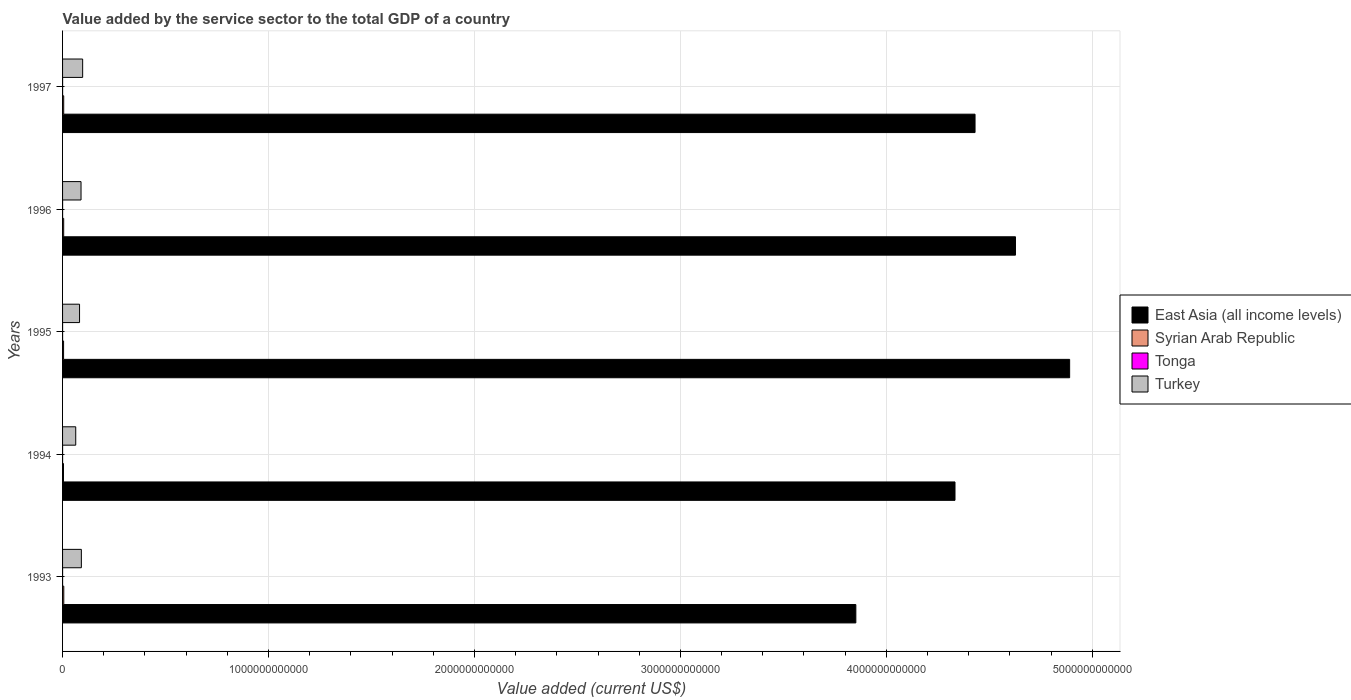Are the number of bars per tick equal to the number of legend labels?
Provide a short and direct response. Yes. Are the number of bars on each tick of the Y-axis equal?
Your answer should be very brief. Yes. In how many cases, is the number of bars for a given year not equal to the number of legend labels?
Offer a very short reply. 0. What is the value added by the service sector to the total GDP in Syrian Arab Republic in 1994?
Your response must be concise. 4.43e+09. Across all years, what is the maximum value added by the service sector to the total GDP in Tonga?
Give a very brief answer. 1.03e+08. Across all years, what is the minimum value added by the service sector to the total GDP in Syrian Arab Republic?
Provide a short and direct response. 4.43e+09. In which year was the value added by the service sector to the total GDP in East Asia (all income levels) maximum?
Offer a terse response. 1995. In which year was the value added by the service sector to the total GDP in Turkey minimum?
Keep it short and to the point. 1994. What is the total value added by the service sector to the total GDP in Turkey in the graph?
Your response must be concise. 4.25e+11. What is the difference between the value added by the service sector to the total GDP in Turkey in 1994 and that in 1995?
Your response must be concise. -1.85e+1. What is the difference between the value added by the service sector to the total GDP in Tonga in 1995 and the value added by the service sector to the total GDP in Turkey in 1997?
Your response must be concise. -9.75e+1. What is the average value added by the service sector to the total GDP in Syrian Arab Republic per year?
Your response must be concise. 5.23e+09. In the year 1995, what is the difference between the value added by the service sector to the total GDP in Syrian Arab Republic and value added by the service sector to the total GDP in East Asia (all income levels)?
Your answer should be compact. -4.88e+12. What is the ratio of the value added by the service sector to the total GDP in Turkey in 1994 to that in 1996?
Offer a very short reply. 0.71. Is the value added by the service sector to the total GDP in Turkey in 1996 less than that in 1997?
Your answer should be very brief. Yes. Is the difference between the value added by the service sector to the total GDP in Syrian Arab Republic in 1995 and 1997 greater than the difference between the value added by the service sector to the total GDP in East Asia (all income levels) in 1995 and 1997?
Offer a terse response. No. What is the difference between the highest and the second highest value added by the service sector to the total GDP in East Asia (all income levels)?
Your response must be concise. 2.63e+11. What is the difference between the highest and the lowest value added by the service sector to the total GDP in Tonga?
Your answer should be compact. 4.81e+07. In how many years, is the value added by the service sector to the total GDP in East Asia (all income levels) greater than the average value added by the service sector to the total GDP in East Asia (all income levels) taken over all years?
Ensure brevity in your answer.  3. Is the sum of the value added by the service sector to the total GDP in Tonga in 1993 and 1997 greater than the maximum value added by the service sector to the total GDP in East Asia (all income levels) across all years?
Ensure brevity in your answer.  No. What does the 2nd bar from the top in 1993 represents?
Give a very brief answer. Tonga. What does the 1st bar from the bottom in 1995 represents?
Make the answer very short. East Asia (all income levels). How many years are there in the graph?
Your answer should be compact. 5. What is the difference between two consecutive major ticks on the X-axis?
Your answer should be compact. 1.00e+12. Are the values on the major ticks of X-axis written in scientific E-notation?
Your answer should be compact. No. Does the graph contain any zero values?
Give a very brief answer. No. Where does the legend appear in the graph?
Keep it short and to the point. Center right. What is the title of the graph?
Provide a succinct answer. Value added by the service sector to the total GDP of a country. Does "Liberia" appear as one of the legend labels in the graph?
Your response must be concise. No. What is the label or title of the X-axis?
Offer a very short reply. Value added (current US$). What is the Value added (current US$) of East Asia (all income levels) in 1993?
Your response must be concise. 3.85e+12. What is the Value added (current US$) of Syrian Arab Republic in 1993?
Ensure brevity in your answer.  5.89e+09. What is the Value added (current US$) of Tonga in 1993?
Your response must be concise. 5.46e+07. What is the Value added (current US$) in Turkey in 1993?
Ensure brevity in your answer.  9.13e+1. What is the Value added (current US$) in East Asia (all income levels) in 1994?
Your response must be concise. 4.33e+12. What is the Value added (current US$) in Syrian Arab Republic in 1994?
Give a very brief answer. 4.43e+09. What is the Value added (current US$) of Tonga in 1994?
Ensure brevity in your answer.  9.02e+07. What is the Value added (current US$) in Turkey in 1994?
Offer a very short reply. 6.40e+1. What is the Value added (current US$) in East Asia (all income levels) in 1995?
Provide a short and direct response. 4.89e+12. What is the Value added (current US$) of Syrian Arab Republic in 1995?
Your answer should be compact. 4.90e+09. What is the Value added (current US$) in Tonga in 1995?
Your answer should be compact. 9.17e+07. What is the Value added (current US$) in Turkey in 1995?
Your answer should be compact. 8.24e+1. What is the Value added (current US$) in East Asia (all income levels) in 1996?
Give a very brief answer. 4.63e+12. What is the Value added (current US$) in Syrian Arab Republic in 1996?
Ensure brevity in your answer.  5.42e+09. What is the Value added (current US$) in Tonga in 1996?
Give a very brief answer. 1.03e+08. What is the Value added (current US$) of Turkey in 1996?
Ensure brevity in your answer.  8.97e+1. What is the Value added (current US$) of East Asia (all income levels) in 1997?
Offer a very short reply. 4.43e+12. What is the Value added (current US$) in Syrian Arab Republic in 1997?
Ensure brevity in your answer.  5.53e+09. What is the Value added (current US$) of Tonga in 1997?
Offer a very short reply. 1.03e+08. What is the Value added (current US$) in Turkey in 1997?
Offer a very short reply. 9.76e+1. Across all years, what is the maximum Value added (current US$) of East Asia (all income levels)?
Ensure brevity in your answer.  4.89e+12. Across all years, what is the maximum Value added (current US$) of Syrian Arab Republic?
Offer a very short reply. 5.89e+09. Across all years, what is the maximum Value added (current US$) of Tonga?
Provide a short and direct response. 1.03e+08. Across all years, what is the maximum Value added (current US$) in Turkey?
Your answer should be compact. 9.76e+1. Across all years, what is the minimum Value added (current US$) in East Asia (all income levels)?
Keep it short and to the point. 3.85e+12. Across all years, what is the minimum Value added (current US$) of Syrian Arab Republic?
Give a very brief answer. 4.43e+09. Across all years, what is the minimum Value added (current US$) in Tonga?
Make the answer very short. 5.46e+07. Across all years, what is the minimum Value added (current US$) of Turkey?
Offer a terse response. 6.40e+1. What is the total Value added (current US$) of East Asia (all income levels) in the graph?
Make the answer very short. 2.21e+13. What is the total Value added (current US$) of Syrian Arab Republic in the graph?
Your response must be concise. 2.62e+1. What is the total Value added (current US$) in Tonga in the graph?
Provide a short and direct response. 4.42e+08. What is the total Value added (current US$) of Turkey in the graph?
Your response must be concise. 4.25e+11. What is the difference between the Value added (current US$) in East Asia (all income levels) in 1993 and that in 1994?
Provide a short and direct response. -4.81e+11. What is the difference between the Value added (current US$) of Syrian Arab Republic in 1993 and that in 1994?
Provide a succinct answer. 1.47e+09. What is the difference between the Value added (current US$) in Tonga in 1993 and that in 1994?
Make the answer very short. -3.56e+07. What is the difference between the Value added (current US$) in Turkey in 1993 and that in 1994?
Give a very brief answer. 2.73e+1. What is the difference between the Value added (current US$) in East Asia (all income levels) in 1993 and that in 1995?
Provide a short and direct response. -1.04e+12. What is the difference between the Value added (current US$) of Syrian Arab Republic in 1993 and that in 1995?
Ensure brevity in your answer.  9.92e+08. What is the difference between the Value added (current US$) of Tonga in 1993 and that in 1995?
Your answer should be very brief. -3.71e+07. What is the difference between the Value added (current US$) in Turkey in 1993 and that in 1995?
Offer a very short reply. 8.86e+09. What is the difference between the Value added (current US$) in East Asia (all income levels) in 1993 and that in 1996?
Your answer should be compact. -7.75e+11. What is the difference between the Value added (current US$) of Syrian Arab Republic in 1993 and that in 1996?
Provide a short and direct response. 4.74e+08. What is the difference between the Value added (current US$) of Tonga in 1993 and that in 1996?
Provide a succinct answer. -4.80e+07. What is the difference between the Value added (current US$) of Turkey in 1993 and that in 1996?
Your answer should be compact. 1.59e+09. What is the difference between the Value added (current US$) in East Asia (all income levels) in 1993 and that in 1997?
Keep it short and to the point. -5.79e+11. What is the difference between the Value added (current US$) in Syrian Arab Republic in 1993 and that in 1997?
Offer a very short reply. 3.67e+08. What is the difference between the Value added (current US$) of Tonga in 1993 and that in 1997?
Your answer should be very brief. -4.81e+07. What is the difference between the Value added (current US$) in Turkey in 1993 and that in 1997?
Keep it short and to the point. -6.27e+09. What is the difference between the Value added (current US$) in East Asia (all income levels) in 1994 and that in 1995?
Make the answer very short. -5.57e+11. What is the difference between the Value added (current US$) in Syrian Arab Republic in 1994 and that in 1995?
Provide a short and direct response. -4.74e+08. What is the difference between the Value added (current US$) of Tonga in 1994 and that in 1995?
Keep it short and to the point. -1.53e+06. What is the difference between the Value added (current US$) in Turkey in 1994 and that in 1995?
Keep it short and to the point. -1.85e+1. What is the difference between the Value added (current US$) in East Asia (all income levels) in 1994 and that in 1996?
Provide a succinct answer. -2.94e+11. What is the difference between the Value added (current US$) in Syrian Arab Republic in 1994 and that in 1996?
Make the answer very short. -9.91e+08. What is the difference between the Value added (current US$) in Tonga in 1994 and that in 1996?
Provide a succinct answer. -1.24e+07. What is the difference between the Value added (current US$) of Turkey in 1994 and that in 1996?
Offer a terse response. -2.57e+1. What is the difference between the Value added (current US$) of East Asia (all income levels) in 1994 and that in 1997?
Give a very brief answer. -9.73e+1. What is the difference between the Value added (current US$) of Syrian Arab Republic in 1994 and that in 1997?
Provide a succinct answer. -1.10e+09. What is the difference between the Value added (current US$) in Tonga in 1994 and that in 1997?
Provide a succinct answer. -1.25e+07. What is the difference between the Value added (current US$) of Turkey in 1994 and that in 1997?
Ensure brevity in your answer.  -3.36e+1. What is the difference between the Value added (current US$) in East Asia (all income levels) in 1995 and that in 1996?
Offer a very short reply. 2.63e+11. What is the difference between the Value added (current US$) of Syrian Arab Republic in 1995 and that in 1996?
Keep it short and to the point. -5.17e+08. What is the difference between the Value added (current US$) in Tonga in 1995 and that in 1996?
Provide a short and direct response. -1.09e+07. What is the difference between the Value added (current US$) of Turkey in 1995 and that in 1996?
Offer a very short reply. -7.28e+09. What is the difference between the Value added (current US$) of East Asia (all income levels) in 1995 and that in 1997?
Offer a terse response. 4.59e+11. What is the difference between the Value added (current US$) of Syrian Arab Republic in 1995 and that in 1997?
Keep it short and to the point. -6.25e+08. What is the difference between the Value added (current US$) of Tonga in 1995 and that in 1997?
Your answer should be very brief. -1.10e+07. What is the difference between the Value added (current US$) in Turkey in 1995 and that in 1997?
Ensure brevity in your answer.  -1.51e+1. What is the difference between the Value added (current US$) in East Asia (all income levels) in 1996 and that in 1997?
Your answer should be very brief. 1.96e+11. What is the difference between the Value added (current US$) of Syrian Arab Republic in 1996 and that in 1997?
Make the answer very short. -1.07e+08. What is the difference between the Value added (current US$) in Tonga in 1996 and that in 1997?
Offer a terse response. -1.17e+05. What is the difference between the Value added (current US$) of Turkey in 1996 and that in 1997?
Your response must be concise. -7.86e+09. What is the difference between the Value added (current US$) in East Asia (all income levels) in 1993 and the Value added (current US$) in Syrian Arab Republic in 1994?
Offer a terse response. 3.85e+12. What is the difference between the Value added (current US$) in East Asia (all income levels) in 1993 and the Value added (current US$) in Tonga in 1994?
Offer a terse response. 3.85e+12. What is the difference between the Value added (current US$) in East Asia (all income levels) in 1993 and the Value added (current US$) in Turkey in 1994?
Offer a terse response. 3.79e+12. What is the difference between the Value added (current US$) of Syrian Arab Republic in 1993 and the Value added (current US$) of Tonga in 1994?
Your answer should be very brief. 5.80e+09. What is the difference between the Value added (current US$) of Syrian Arab Republic in 1993 and the Value added (current US$) of Turkey in 1994?
Make the answer very short. -5.81e+1. What is the difference between the Value added (current US$) in Tonga in 1993 and the Value added (current US$) in Turkey in 1994?
Make the answer very short. -6.39e+1. What is the difference between the Value added (current US$) of East Asia (all income levels) in 1993 and the Value added (current US$) of Syrian Arab Republic in 1995?
Your response must be concise. 3.85e+12. What is the difference between the Value added (current US$) in East Asia (all income levels) in 1993 and the Value added (current US$) in Tonga in 1995?
Give a very brief answer. 3.85e+12. What is the difference between the Value added (current US$) of East Asia (all income levels) in 1993 and the Value added (current US$) of Turkey in 1995?
Your answer should be compact. 3.77e+12. What is the difference between the Value added (current US$) of Syrian Arab Republic in 1993 and the Value added (current US$) of Tonga in 1995?
Offer a very short reply. 5.80e+09. What is the difference between the Value added (current US$) of Syrian Arab Republic in 1993 and the Value added (current US$) of Turkey in 1995?
Make the answer very short. -7.65e+1. What is the difference between the Value added (current US$) of Tonga in 1993 and the Value added (current US$) of Turkey in 1995?
Provide a succinct answer. -8.24e+1. What is the difference between the Value added (current US$) of East Asia (all income levels) in 1993 and the Value added (current US$) of Syrian Arab Republic in 1996?
Keep it short and to the point. 3.85e+12. What is the difference between the Value added (current US$) in East Asia (all income levels) in 1993 and the Value added (current US$) in Tonga in 1996?
Offer a very short reply. 3.85e+12. What is the difference between the Value added (current US$) of East Asia (all income levels) in 1993 and the Value added (current US$) of Turkey in 1996?
Offer a terse response. 3.76e+12. What is the difference between the Value added (current US$) in Syrian Arab Republic in 1993 and the Value added (current US$) in Tonga in 1996?
Provide a short and direct response. 5.79e+09. What is the difference between the Value added (current US$) in Syrian Arab Republic in 1993 and the Value added (current US$) in Turkey in 1996?
Ensure brevity in your answer.  -8.38e+1. What is the difference between the Value added (current US$) in Tonga in 1993 and the Value added (current US$) in Turkey in 1996?
Provide a short and direct response. -8.96e+1. What is the difference between the Value added (current US$) of East Asia (all income levels) in 1993 and the Value added (current US$) of Syrian Arab Republic in 1997?
Your answer should be very brief. 3.85e+12. What is the difference between the Value added (current US$) of East Asia (all income levels) in 1993 and the Value added (current US$) of Tonga in 1997?
Provide a short and direct response. 3.85e+12. What is the difference between the Value added (current US$) in East Asia (all income levels) in 1993 and the Value added (current US$) in Turkey in 1997?
Make the answer very short. 3.75e+12. What is the difference between the Value added (current US$) of Syrian Arab Republic in 1993 and the Value added (current US$) of Tonga in 1997?
Your answer should be very brief. 5.79e+09. What is the difference between the Value added (current US$) in Syrian Arab Republic in 1993 and the Value added (current US$) in Turkey in 1997?
Provide a short and direct response. -9.17e+1. What is the difference between the Value added (current US$) of Tonga in 1993 and the Value added (current US$) of Turkey in 1997?
Make the answer very short. -9.75e+1. What is the difference between the Value added (current US$) of East Asia (all income levels) in 1994 and the Value added (current US$) of Syrian Arab Republic in 1995?
Keep it short and to the point. 4.33e+12. What is the difference between the Value added (current US$) of East Asia (all income levels) in 1994 and the Value added (current US$) of Tonga in 1995?
Give a very brief answer. 4.33e+12. What is the difference between the Value added (current US$) of East Asia (all income levels) in 1994 and the Value added (current US$) of Turkey in 1995?
Your answer should be compact. 4.25e+12. What is the difference between the Value added (current US$) in Syrian Arab Republic in 1994 and the Value added (current US$) in Tonga in 1995?
Give a very brief answer. 4.34e+09. What is the difference between the Value added (current US$) of Syrian Arab Republic in 1994 and the Value added (current US$) of Turkey in 1995?
Provide a succinct answer. -7.80e+1. What is the difference between the Value added (current US$) of Tonga in 1994 and the Value added (current US$) of Turkey in 1995?
Offer a terse response. -8.23e+1. What is the difference between the Value added (current US$) in East Asia (all income levels) in 1994 and the Value added (current US$) in Syrian Arab Republic in 1996?
Your response must be concise. 4.33e+12. What is the difference between the Value added (current US$) of East Asia (all income levels) in 1994 and the Value added (current US$) of Tonga in 1996?
Provide a short and direct response. 4.33e+12. What is the difference between the Value added (current US$) of East Asia (all income levels) in 1994 and the Value added (current US$) of Turkey in 1996?
Your answer should be compact. 4.24e+12. What is the difference between the Value added (current US$) of Syrian Arab Republic in 1994 and the Value added (current US$) of Tonga in 1996?
Your response must be concise. 4.32e+09. What is the difference between the Value added (current US$) in Syrian Arab Republic in 1994 and the Value added (current US$) in Turkey in 1996?
Offer a terse response. -8.53e+1. What is the difference between the Value added (current US$) in Tonga in 1994 and the Value added (current US$) in Turkey in 1996?
Make the answer very short. -8.96e+1. What is the difference between the Value added (current US$) in East Asia (all income levels) in 1994 and the Value added (current US$) in Syrian Arab Republic in 1997?
Ensure brevity in your answer.  4.33e+12. What is the difference between the Value added (current US$) in East Asia (all income levels) in 1994 and the Value added (current US$) in Tonga in 1997?
Your response must be concise. 4.33e+12. What is the difference between the Value added (current US$) in East Asia (all income levels) in 1994 and the Value added (current US$) in Turkey in 1997?
Provide a short and direct response. 4.24e+12. What is the difference between the Value added (current US$) in Syrian Arab Republic in 1994 and the Value added (current US$) in Tonga in 1997?
Keep it short and to the point. 4.32e+09. What is the difference between the Value added (current US$) in Syrian Arab Republic in 1994 and the Value added (current US$) in Turkey in 1997?
Give a very brief answer. -9.31e+1. What is the difference between the Value added (current US$) of Tonga in 1994 and the Value added (current US$) of Turkey in 1997?
Offer a very short reply. -9.75e+1. What is the difference between the Value added (current US$) of East Asia (all income levels) in 1995 and the Value added (current US$) of Syrian Arab Republic in 1996?
Provide a short and direct response. 4.88e+12. What is the difference between the Value added (current US$) in East Asia (all income levels) in 1995 and the Value added (current US$) in Tonga in 1996?
Make the answer very short. 4.89e+12. What is the difference between the Value added (current US$) of East Asia (all income levels) in 1995 and the Value added (current US$) of Turkey in 1996?
Ensure brevity in your answer.  4.80e+12. What is the difference between the Value added (current US$) of Syrian Arab Republic in 1995 and the Value added (current US$) of Tonga in 1996?
Make the answer very short. 4.80e+09. What is the difference between the Value added (current US$) in Syrian Arab Republic in 1995 and the Value added (current US$) in Turkey in 1996?
Your answer should be compact. -8.48e+1. What is the difference between the Value added (current US$) in Tonga in 1995 and the Value added (current US$) in Turkey in 1996?
Ensure brevity in your answer.  -8.96e+1. What is the difference between the Value added (current US$) of East Asia (all income levels) in 1995 and the Value added (current US$) of Syrian Arab Republic in 1997?
Provide a succinct answer. 4.88e+12. What is the difference between the Value added (current US$) in East Asia (all income levels) in 1995 and the Value added (current US$) in Tonga in 1997?
Make the answer very short. 4.89e+12. What is the difference between the Value added (current US$) of East Asia (all income levels) in 1995 and the Value added (current US$) of Turkey in 1997?
Give a very brief answer. 4.79e+12. What is the difference between the Value added (current US$) in Syrian Arab Republic in 1995 and the Value added (current US$) in Tonga in 1997?
Offer a very short reply. 4.80e+09. What is the difference between the Value added (current US$) in Syrian Arab Republic in 1995 and the Value added (current US$) in Turkey in 1997?
Your answer should be compact. -9.27e+1. What is the difference between the Value added (current US$) of Tonga in 1995 and the Value added (current US$) of Turkey in 1997?
Provide a succinct answer. -9.75e+1. What is the difference between the Value added (current US$) in East Asia (all income levels) in 1996 and the Value added (current US$) in Syrian Arab Republic in 1997?
Ensure brevity in your answer.  4.62e+12. What is the difference between the Value added (current US$) in East Asia (all income levels) in 1996 and the Value added (current US$) in Tonga in 1997?
Keep it short and to the point. 4.63e+12. What is the difference between the Value added (current US$) in East Asia (all income levels) in 1996 and the Value added (current US$) in Turkey in 1997?
Ensure brevity in your answer.  4.53e+12. What is the difference between the Value added (current US$) of Syrian Arab Republic in 1996 and the Value added (current US$) of Tonga in 1997?
Provide a short and direct response. 5.32e+09. What is the difference between the Value added (current US$) in Syrian Arab Republic in 1996 and the Value added (current US$) in Turkey in 1997?
Provide a short and direct response. -9.21e+1. What is the difference between the Value added (current US$) of Tonga in 1996 and the Value added (current US$) of Turkey in 1997?
Offer a very short reply. -9.74e+1. What is the average Value added (current US$) of East Asia (all income levels) per year?
Your answer should be compact. 4.43e+12. What is the average Value added (current US$) of Syrian Arab Republic per year?
Ensure brevity in your answer.  5.23e+09. What is the average Value added (current US$) in Tonga per year?
Your answer should be very brief. 8.84e+07. What is the average Value added (current US$) of Turkey per year?
Offer a very short reply. 8.50e+1. In the year 1993, what is the difference between the Value added (current US$) in East Asia (all income levels) and Value added (current US$) in Syrian Arab Republic?
Offer a very short reply. 3.85e+12. In the year 1993, what is the difference between the Value added (current US$) in East Asia (all income levels) and Value added (current US$) in Tonga?
Provide a succinct answer. 3.85e+12. In the year 1993, what is the difference between the Value added (current US$) in East Asia (all income levels) and Value added (current US$) in Turkey?
Ensure brevity in your answer.  3.76e+12. In the year 1993, what is the difference between the Value added (current US$) in Syrian Arab Republic and Value added (current US$) in Tonga?
Your answer should be very brief. 5.84e+09. In the year 1993, what is the difference between the Value added (current US$) in Syrian Arab Republic and Value added (current US$) in Turkey?
Provide a short and direct response. -8.54e+1. In the year 1993, what is the difference between the Value added (current US$) of Tonga and Value added (current US$) of Turkey?
Keep it short and to the point. -9.12e+1. In the year 1994, what is the difference between the Value added (current US$) in East Asia (all income levels) and Value added (current US$) in Syrian Arab Republic?
Give a very brief answer. 4.33e+12. In the year 1994, what is the difference between the Value added (current US$) in East Asia (all income levels) and Value added (current US$) in Tonga?
Give a very brief answer. 4.33e+12. In the year 1994, what is the difference between the Value added (current US$) in East Asia (all income levels) and Value added (current US$) in Turkey?
Your response must be concise. 4.27e+12. In the year 1994, what is the difference between the Value added (current US$) in Syrian Arab Republic and Value added (current US$) in Tonga?
Provide a succinct answer. 4.34e+09. In the year 1994, what is the difference between the Value added (current US$) in Syrian Arab Republic and Value added (current US$) in Turkey?
Ensure brevity in your answer.  -5.95e+1. In the year 1994, what is the difference between the Value added (current US$) of Tonga and Value added (current US$) of Turkey?
Provide a succinct answer. -6.39e+1. In the year 1995, what is the difference between the Value added (current US$) in East Asia (all income levels) and Value added (current US$) in Syrian Arab Republic?
Make the answer very short. 4.88e+12. In the year 1995, what is the difference between the Value added (current US$) in East Asia (all income levels) and Value added (current US$) in Tonga?
Your response must be concise. 4.89e+12. In the year 1995, what is the difference between the Value added (current US$) in East Asia (all income levels) and Value added (current US$) in Turkey?
Offer a terse response. 4.81e+12. In the year 1995, what is the difference between the Value added (current US$) of Syrian Arab Republic and Value added (current US$) of Tonga?
Make the answer very short. 4.81e+09. In the year 1995, what is the difference between the Value added (current US$) of Syrian Arab Republic and Value added (current US$) of Turkey?
Your answer should be compact. -7.75e+1. In the year 1995, what is the difference between the Value added (current US$) in Tonga and Value added (current US$) in Turkey?
Give a very brief answer. -8.23e+1. In the year 1996, what is the difference between the Value added (current US$) of East Asia (all income levels) and Value added (current US$) of Syrian Arab Republic?
Your response must be concise. 4.62e+12. In the year 1996, what is the difference between the Value added (current US$) in East Asia (all income levels) and Value added (current US$) in Tonga?
Provide a succinct answer. 4.63e+12. In the year 1996, what is the difference between the Value added (current US$) in East Asia (all income levels) and Value added (current US$) in Turkey?
Provide a succinct answer. 4.54e+12. In the year 1996, what is the difference between the Value added (current US$) in Syrian Arab Republic and Value added (current US$) in Tonga?
Keep it short and to the point. 5.32e+09. In the year 1996, what is the difference between the Value added (current US$) of Syrian Arab Republic and Value added (current US$) of Turkey?
Offer a very short reply. -8.43e+1. In the year 1996, what is the difference between the Value added (current US$) in Tonga and Value added (current US$) in Turkey?
Ensure brevity in your answer.  -8.96e+1. In the year 1997, what is the difference between the Value added (current US$) in East Asia (all income levels) and Value added (current US$) in Syrian Arab Republic?
Offer a terse response. 4.43e+12. In the year 1997, what is the difference between the Value added (current US$) in East Asia (all income levels) and Value added (current US$) in Tonga?
Make the answer very short. 4.43e+12. In the year 1997, what is the difference between the Value added (current US$) of East Asia (all income levels) and Value added (current US$) of Turkey?
Offer a very short reply. 4.33e+12. In the year 1997, what is the difference between the Value added (current US$) in Syrian Arab Republic and Value added (current US$) in Tonga?
Ensure brevity in your answer.  5.42e+09. In the year 1997, what is the difference between the Value added (current US$) of Syrian Arab Republic and Value added (current US$) of Turkey?
Ensure brevity in your answer.  -9.20e+1. In the year 1997, what is the difference between the Value added (current US$) in Tonga and Value added (current US$) in Turkey?
Make the answer very short. -9.74e+1. What is the ratio of the Value added (current US$) of Syrian Arab Republic in 1993 to that in 1994?
Make the answer very short. 1.33. What is the ratio of the Value added (current US$) in Tonga in 1993 to that in 1994?
Offer a terse response. 0.61. What is the ratio of the Value added (current US$) of Turkey in 1993 to that in 1994?
Give a very brief answer. 1.43. What is the ratio of the Value added (current US$) of East Asia (all income levels) in 1993 to that in 1995?
Your answer should be compact. 0.79. What is the ratio of the Value added (current US$) of Syrian Arab Republic in 1993 to that in 1995?
Offer a terse response. 1.2. What is the ratio of the Value added (current US$) in Tonga in 1993 to that in 1995?
Keep it short and to the point. 0.6. What is the ratio of the Value added (current US$) in Turkey in 1993 to that in 1995?
Provide a succinct answer. 1.11. What is the ratio of the Value added (current US$) in East Asia (all income levels) in 1993 to that in 1996?
Your response must be concise. 0.83. What is the ratio of the Value added (current US$) in Syrian Arab Republic in 1993 to that in 1996?
Offer a very short reply. 1.09. What is the ratio of the Value added (current US$) in Tonga in 1993 to that in 1996?
Your answer should be compact. 0.53. What is the ratio of the Value added (current US$) in Turkey in 1993 to that in 1996?
Provide a succinct answer. 1.02. What is the ratio of the Value added (current US$) in East Asia (all income levels) in 1993 to that in 1997?
Provide a succinct answer. 0.87. What is the ratio of the Value added (current US$) in Syrian Arab Republic in 1993 to that in 1997?
Ensure brevity in your answer.  1.07. What is the ratio of the Value added (current US$) in Tonga in 1993 to that in 1997?
Your response must be concise. 0.53. What is the ratio of the Value added (current US$) of Turkey in 1993 to that in 1997?
Your response must be concise. 0.94. What is the ratio of the Value added (current US$) of East Asia (all income levels) in 1994 to that in 1995?
Provide a succinct answer. 0.89. What is the ratio of the Value added (current US$) of Syrian Arab Republic in 1994 to that in 1995?
Provide a short and direct response. 0.9. What is the ratio of the Value added (current US$) in Tonga in 1994 to that in 1995?
Provide a short and direct response. 0.98. What is the ratio of the Value added (current US$) of Turkey in 1994 to that in 1995?
Give a very brief answer. 0.78. What is the ratio of the Value added (current US$) of East Asia (all income levels) in 1994 to that in 1996?
Your response must be concise. 0.94. What is the ratio of the Value added (current US$) of Syrian Arab Republic in 1994 to that in 1996?
Provide a short and direct response. 0.82. What is the ratio of the Value added (current US$) in Tonga in 1994 to that in 1996?
Your answer should be compact. 0.88. What is the ratio of the Value added (current US$) of Turkey in 1994 to that in 1996?
Your answer should be compact. 0.71. What is the ratio of the Value added (current US$) of East Asia (all income levels) in 1994 to that in 1997?
Ensure brevity in your answer.  0.98. What is the ratio of the Value added (current US$) of Syrian Arab Republic in 1994 to that in 1997?
Your answer should be very brief. 0.8. What is the ratio of the Value added (current US$) of Tonga in 1994 to that in 1997?
Your answer should be very brief. 0.88. What is the ratio of the Value added (current US$) in Turkey in 1994 to that in 1997?
Provide a short and direct response. 0.66. What is the ratio of the Value added (current US$) in East Asia (all income levels) in 1995 to that in 1996?
Your response must be concise. 1.06. What is the ratio of the Value added (current US$) of Syrian Arab Republic in 1995 to that in 1996?
Offer a very short reply. 0.9. What is the ratio of the Value added (current US$) of Tonga in 1995 to that in 1996?
Your answer should be compact. 0.89. What is the ratio of the Value added (current US$) of Turkey in 1995 to that in 1996?
Offer a very short reply. 0.92. What is the ratio of the Value added (current US$) of East Asia (all income levels) in 1995 to that in 1997?
Make the answer very short. 1.1. What is the ratio of the Value added (current US$) of Syrian Arab Republic in 1995 to that in 1997?
Your answer should be compact. 0.89. What is the ratio of the Value added (current US$) of Tonga in 1995 to that in 1997?
Offer a very short reply. 0.89. What is the ratio of the Value added (current US$) of Turkey in 1995 to that in 1997?
Your response must be concise. 0.84. What is the ratio of the Value added (current US$) in East Asia (all income levels) in 1996 to that in 1997?
Offer a terse response. 1.04. What is the ratio of the Value added (current US$) in Syrian Arab Republic in 1996 to that in 1997?
Offer a terse response. 0.98. What is the ratio of the Value added (current US$) in Tonga in 1996 to that in 1997?
Your response must be concise. 1. What is the ratio of the Value added (current US$) in Turkey in 1996 to that in 1997?
Your response must be concise. 0.92. What is the difference between the highest and the second highest Value added (current US$) in East Asia (all income levels)?
Make the answer very short. 2.63e+11. What is the difference between the highest and the second highest Value added (current US$) in Syrian Arab Republic?
Give a very brief answer. 3.67e+08. What is the difference between the highest and the second highest Value added (current US$) of Tonga?
Give a very brief answer. 1.17e+05. What is the difference between the highest and the second highest Value added (current US$) in Turkey?
Keep it short and to the point. 6.27e+09. What is the difference between the highest and the lowest Value added (current US$) in East Asia (all income levels)?
Make the answer very short. 1.04e+12. What is the difference between the highest and the lowest Value added (current US$) in Syrian Arab Republic?
Your answer should be compact. 1.47e+09. What is the difference between the highest and the lowest Value added (current US$) of Tonga?
Provide a succinct answer. 4.81e+07. What is the difference between the highest and the lowest Value added (current US$) of Turkey?
Make the answer very short. 3.36e+1. 